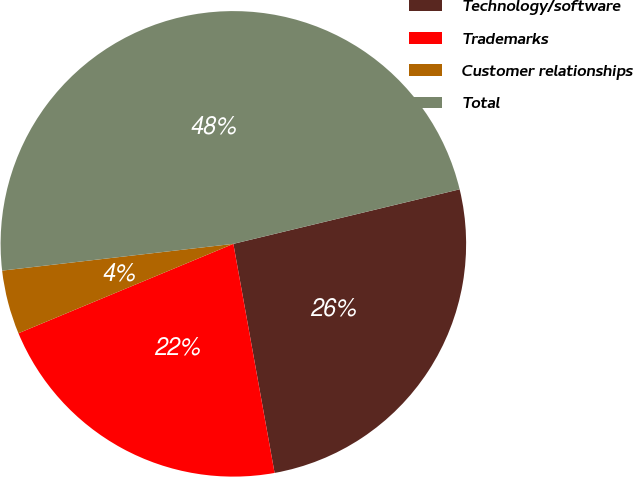<chart> <loc_0><loc_0><loc_500><loc_500><pie_chart><fcel>Technology/software<fcel>Trademarks<fcel>Customer relationships<fcel>Total<nl><fcel>25.93%<fcel>21.56%<fcel>4.44%<fcel>48.07%<nl></chart> 